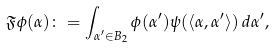<formula> <loc_0><loc_0><loc_500><loc_500>\mathfrak { F } \phi ( \alpha ) \colon = \int _ { \alpha ^ { \prime } \in B _ { 2 } } \phi ( \alpha ^ { \prime } ) \psi ( \langle \alpha , \alpha ^ { \prime } \rangle ) \, d \alpha ^ { \prime } ,</formula> 